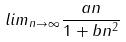Convert formula to latex. <formula><loc_0><loc_0><loc_500><loc_500>l i m _ { n \rightarrow \infty } \frac { a n } { 1 + b n ^ { 2 } }</formula> 